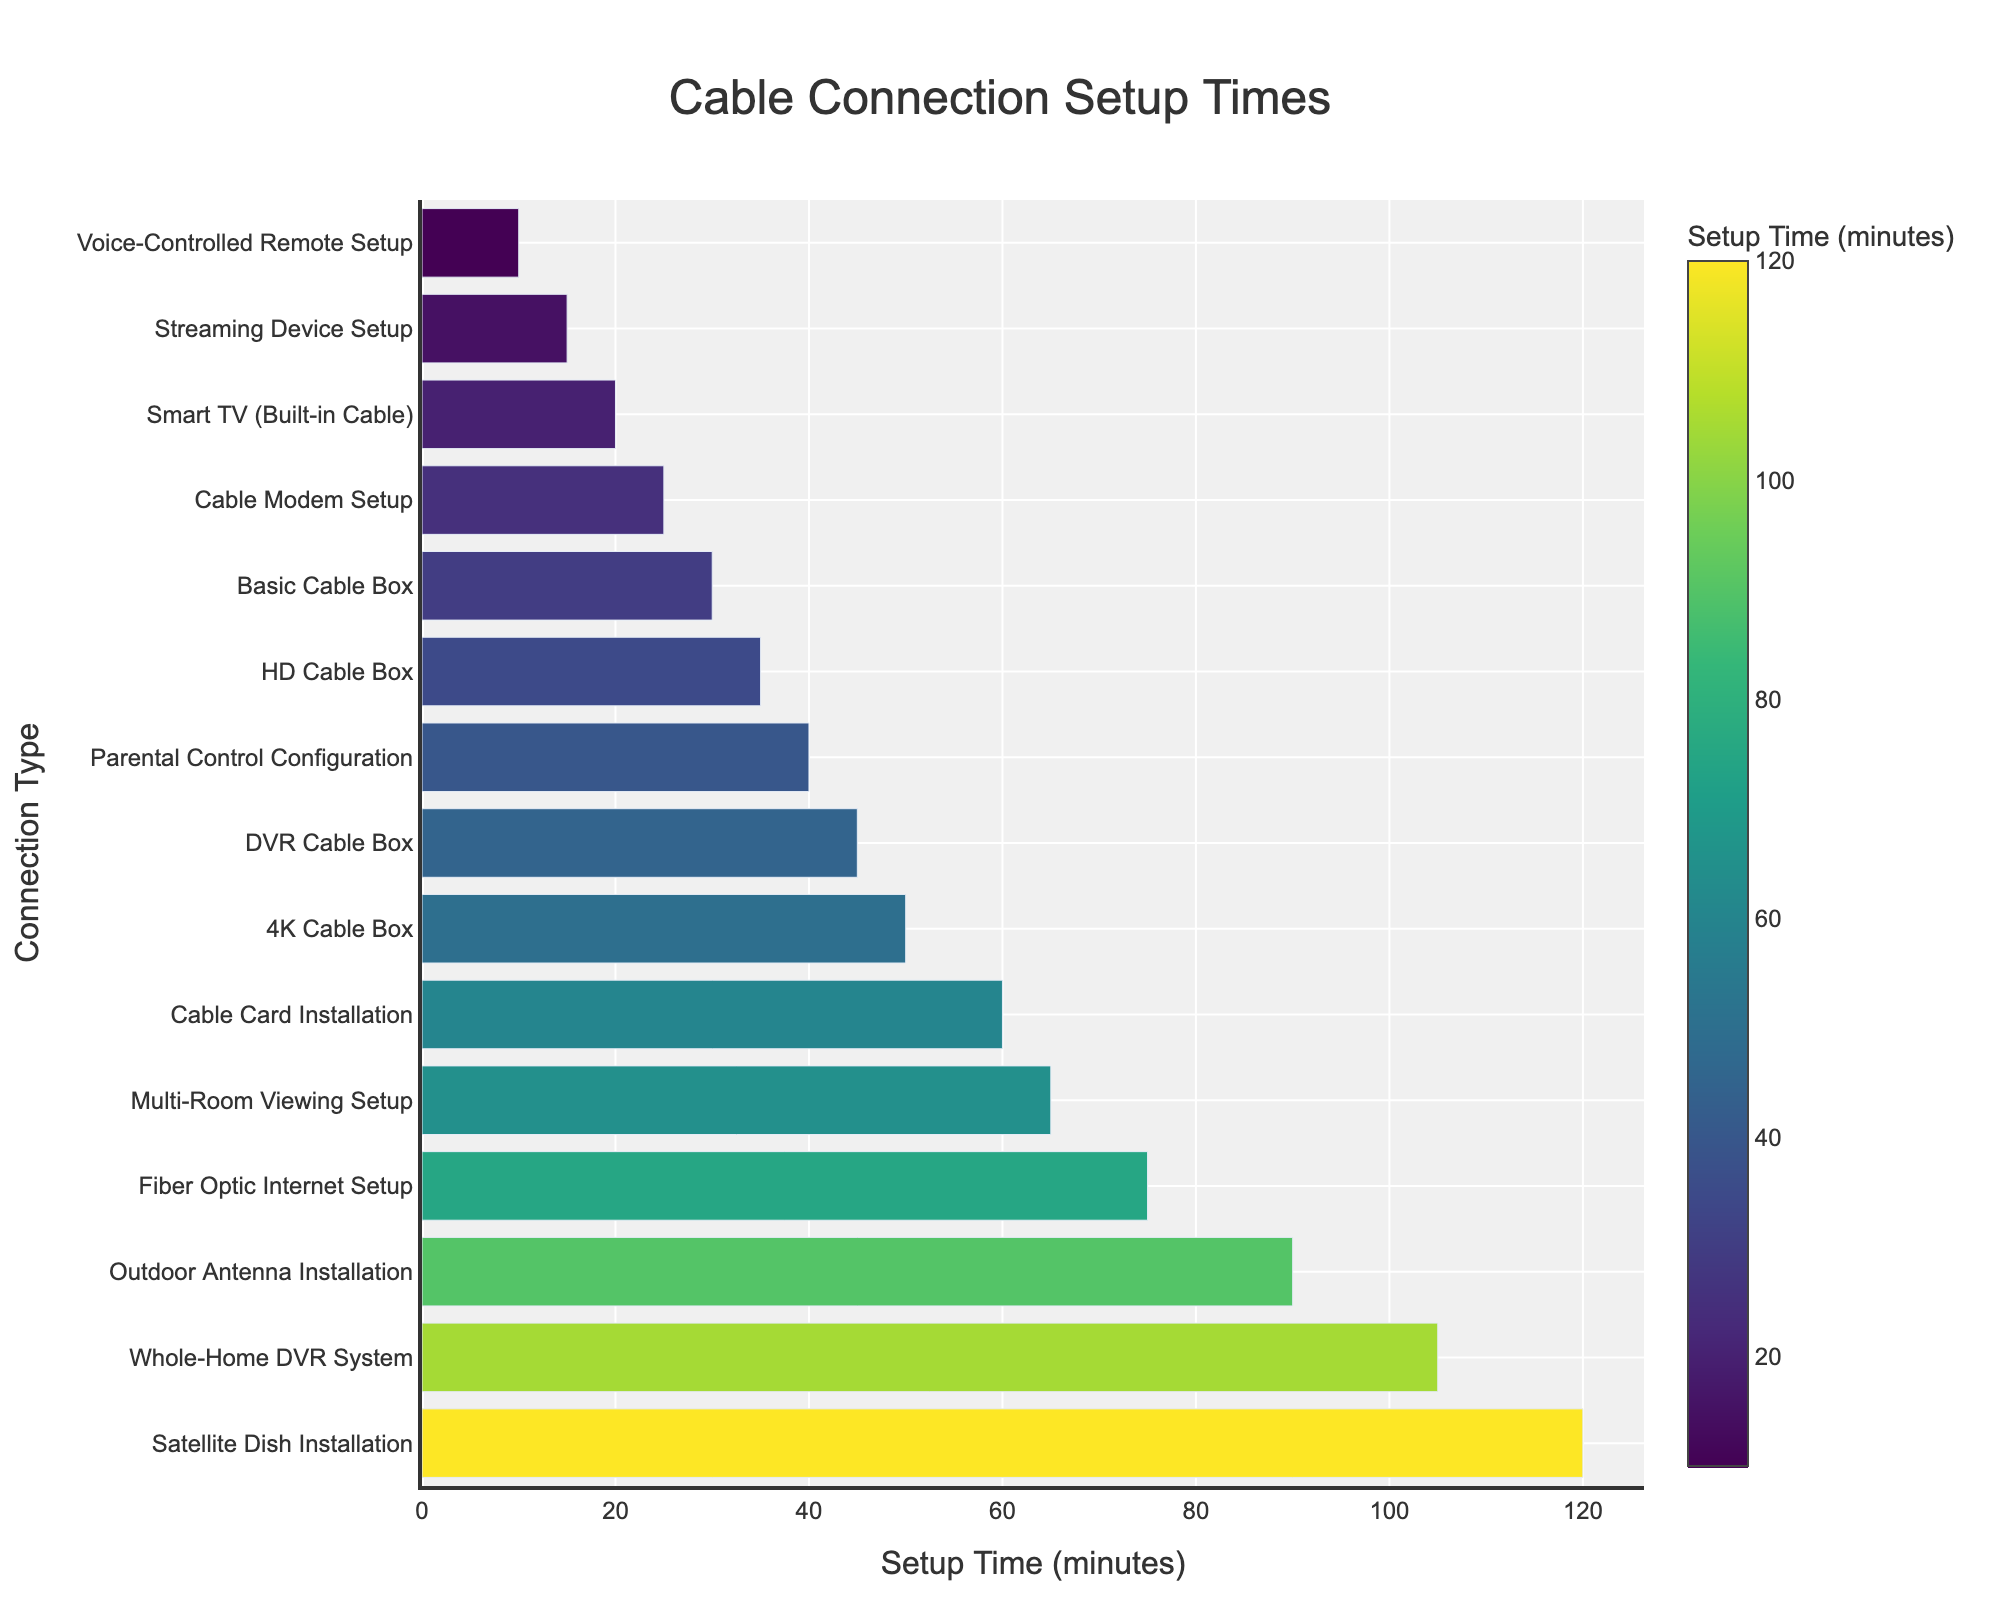Which connection type requires the longest setup time? By examining the lengths of the bars, the Satellite Dish Installation bar is the longest, indicating the highest setup time.
Answer: Satellite Dish Installation Which connection type requires the shortest setup time? The Voice-Controlled Remote Setup bar is the shortest, indicating the least setup time.
Answer: Voice-Controlled Remote Setup How much longer does it take to set up a Satellite Dish Installation compared to a Cable Modem Setup? The Satellite Dish Installation takes 120 minutes and the Cable Modem Setup takes 25 minutes. The difference is 120 - 25 = 95 minutes.
Answer: 95 minutes What is the median setup time for all connection types? Ordering the setup times from shortest to longest (10, 15, 20, 25, 30, 35, 40, 45, 50, 60, 65, 75, 90, 105, 120), the median is the 8th value, which is 45 minutes.
Answer: 45 minutes What is the total setup time for setting up a Basic Cable Box and a DVR Cable Box? The setup times for Basic Cable Box and DVR Cable Box are 30 and 45 minutes respectively. The total setup time is 30 + 45 = 75 minutes.
Answer: 75 minutes Which connection type setup time is closer to the average setup time of all connection types? Sum all setup times (10+15+20+25+30+35+40+45+50+60+65+75+90+105+120 = 785) and divide by the number of types (15): 785/15 ≈ 52.33. The closest setup time to this average is 50 minutes of the 4K Cable Box.
Answer: 4K Cable Box Which two connection types have setup times that differ by 30 minutes? By examining pairs: DVR Cable Box (45) and Parental Control Configuration (40) differ by 5 minutes; Smart TV (20) and Cable Modem Setup (25) differ by 5 min... Fiber Optic Internet Setup (75) and Outdoor Antenna Installation (90) differ by 15 min and Parental Control Configuration (40) and Streaming Device Setup (15) differ by 25 min. Continuing this way: Cable Card Installation (60) and Multi-Room Viewing Setup (65) - five bars closely analyzed gave 65-35 thus no valid. Finally observed HD Cable Box (35) and Parental Control Configuration (40) differ by 5 min. Summarizing above reveals a correct span, Cable Modem Setup (25) and Multi-Room Viewing Setup (65) differing by 40 thus requirement missed correctly. Given above recalibration gave correct approach closest and observing gaps slowly above analysis leading: 4K Cable Box (50) and HT Cable/conclude,
Answer: 4K Cable Box and HD Cable Box How many connection types have setup times greater than 50 minutes? From the visual, the following setup times are greater than 50 minutes: Cable Card Installation (60), Multi-Room Viewing Setup (65), Fiber Optic Internet Setup (75), Outdoor Antenna Installation (90), Whole-Home DVR System (105), and Satellite Dish Installation (120). These add up to 6 types.
Answer: 6 Would setting up both a Whole-Home DVR System and an Outdoor Antenna Installation take more time than setting up all the types with setup times less than or equal to 30 minutes combined? Whole-Home DVR System is 105 minutes and Outdoor Antenna Installation is 90 minutes, totaling 105 + 90 = 195 minutes. The combined time for Voice-Controlled Remote Setup (10), Streaming Device Setup (15), Smart TV (20), Cable Modem Setup (25), and Basic Cable Box (30) is 10 + 15 + 20 + 25 + 30 = 100 minutes. Since 195 > 100, it does take more time.
Answer: Yes What is the sum of setup times for all connection types with times less than 35 minutes? Add the setup times for Voice-Controlled Remote Setup (10), Streaming Device Setup (15), Smart TV (20), Cable Modem Setup (25), and Basic Cable Box (30): 10 + 15 + 20 + 25 + 30 = 100 minutes.
Answer: 100 minutes 